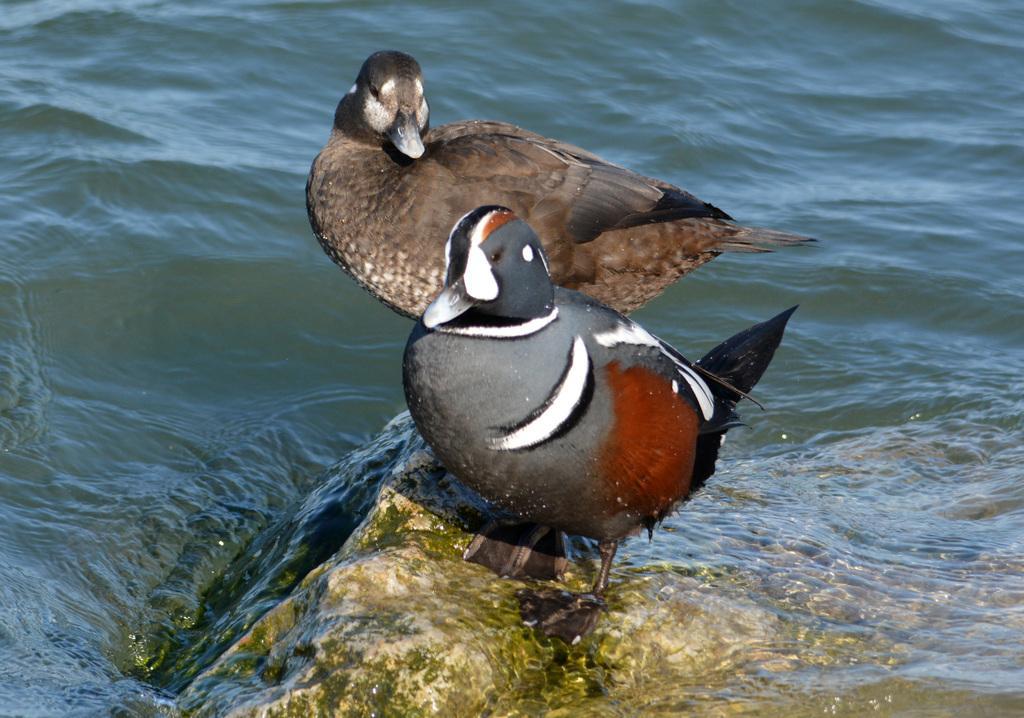Describe this image in one or two sentences. In this picture, we see two birds are on the rock. In the background, we see water and this water might be in the lake. 